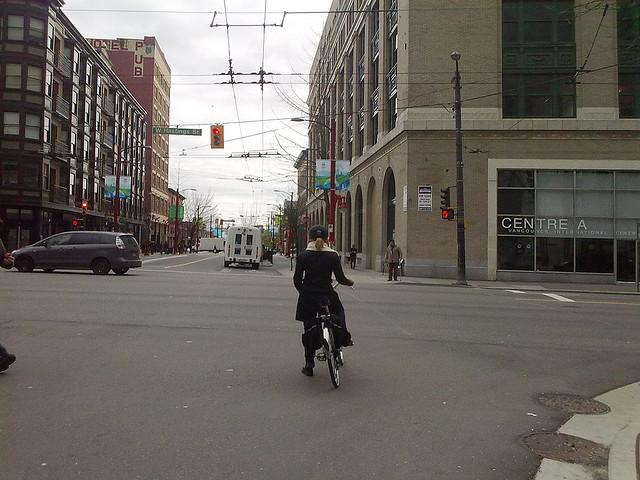What province is she riding in? Please explain your reasoning. british columbia. The words on the building window are in french. 